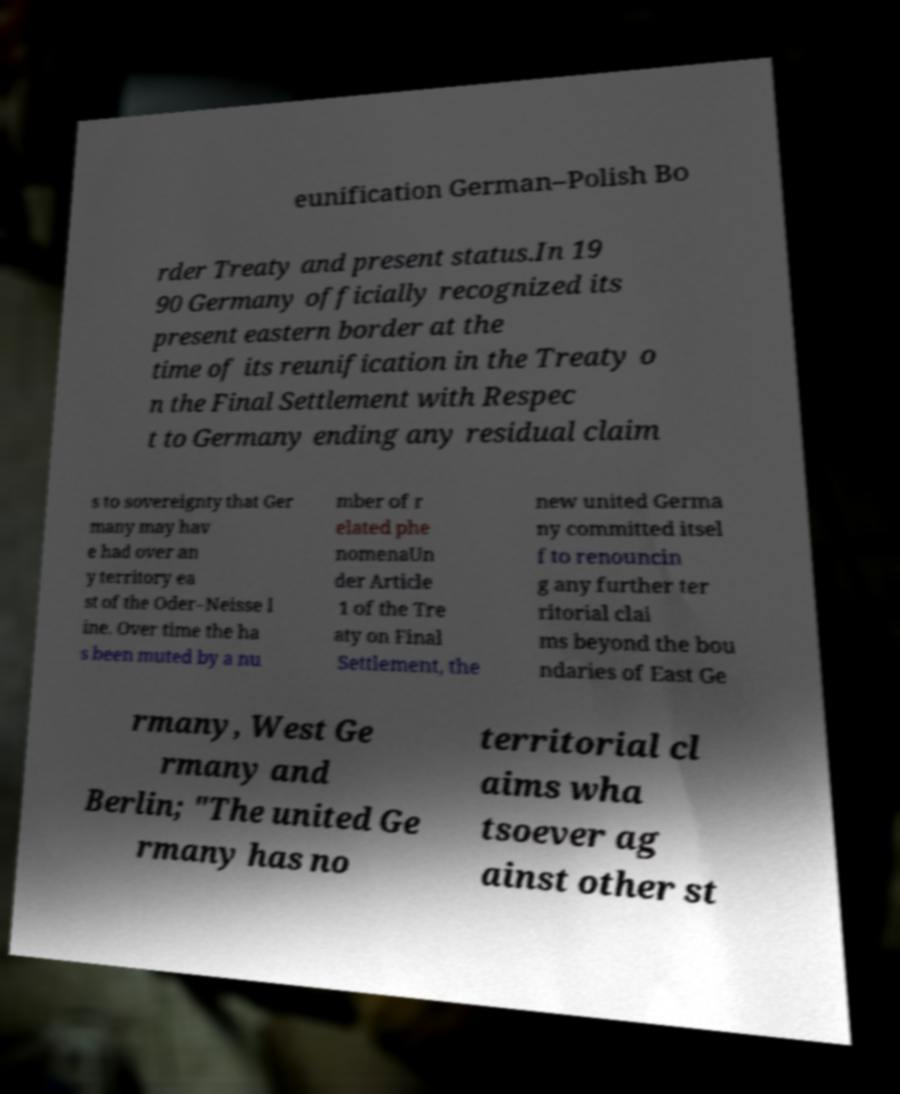Please read and relay the text visible in this image. What does it say? eunification German–Polish Bo rder Treaty and present status.In 19 90 Germany officially recognized its present eastern border at the time of its reunification in the Treaty o n the Final Settlement with Respec t to Germany ending any residual claim s to sovereignty that Ger many may hav e had over an y territory ea st of the Oder–Neisse l ine. Over time the ha s been muted by a nu mber of r elated phe nomenaUn der Article 1 of the Tre aty on Final Settlement, the new united Germa ny committed itsel f to renouncin g any further ter ritorial clai ms beyond the bou ndaries of East Ge rmany, West Ge rmany and Berlin; "The united Ge rmany has no territorial cl aims wha tsoever ag ainst other st 